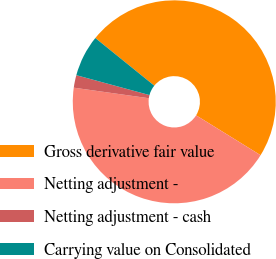Convert chart. <chart><loc_0><loc_0><loc_500><loc_500><pie_chart><fcel>Gross derivative fair value<fcel>Netting adjustment -<fcel>Netting adjustment - cash<fcel>Carrying value on Consolidated<nl><fcel>48.0%<fcel>43.41%<fcel>2.0%<fcel>6.59%<nl></chart> 